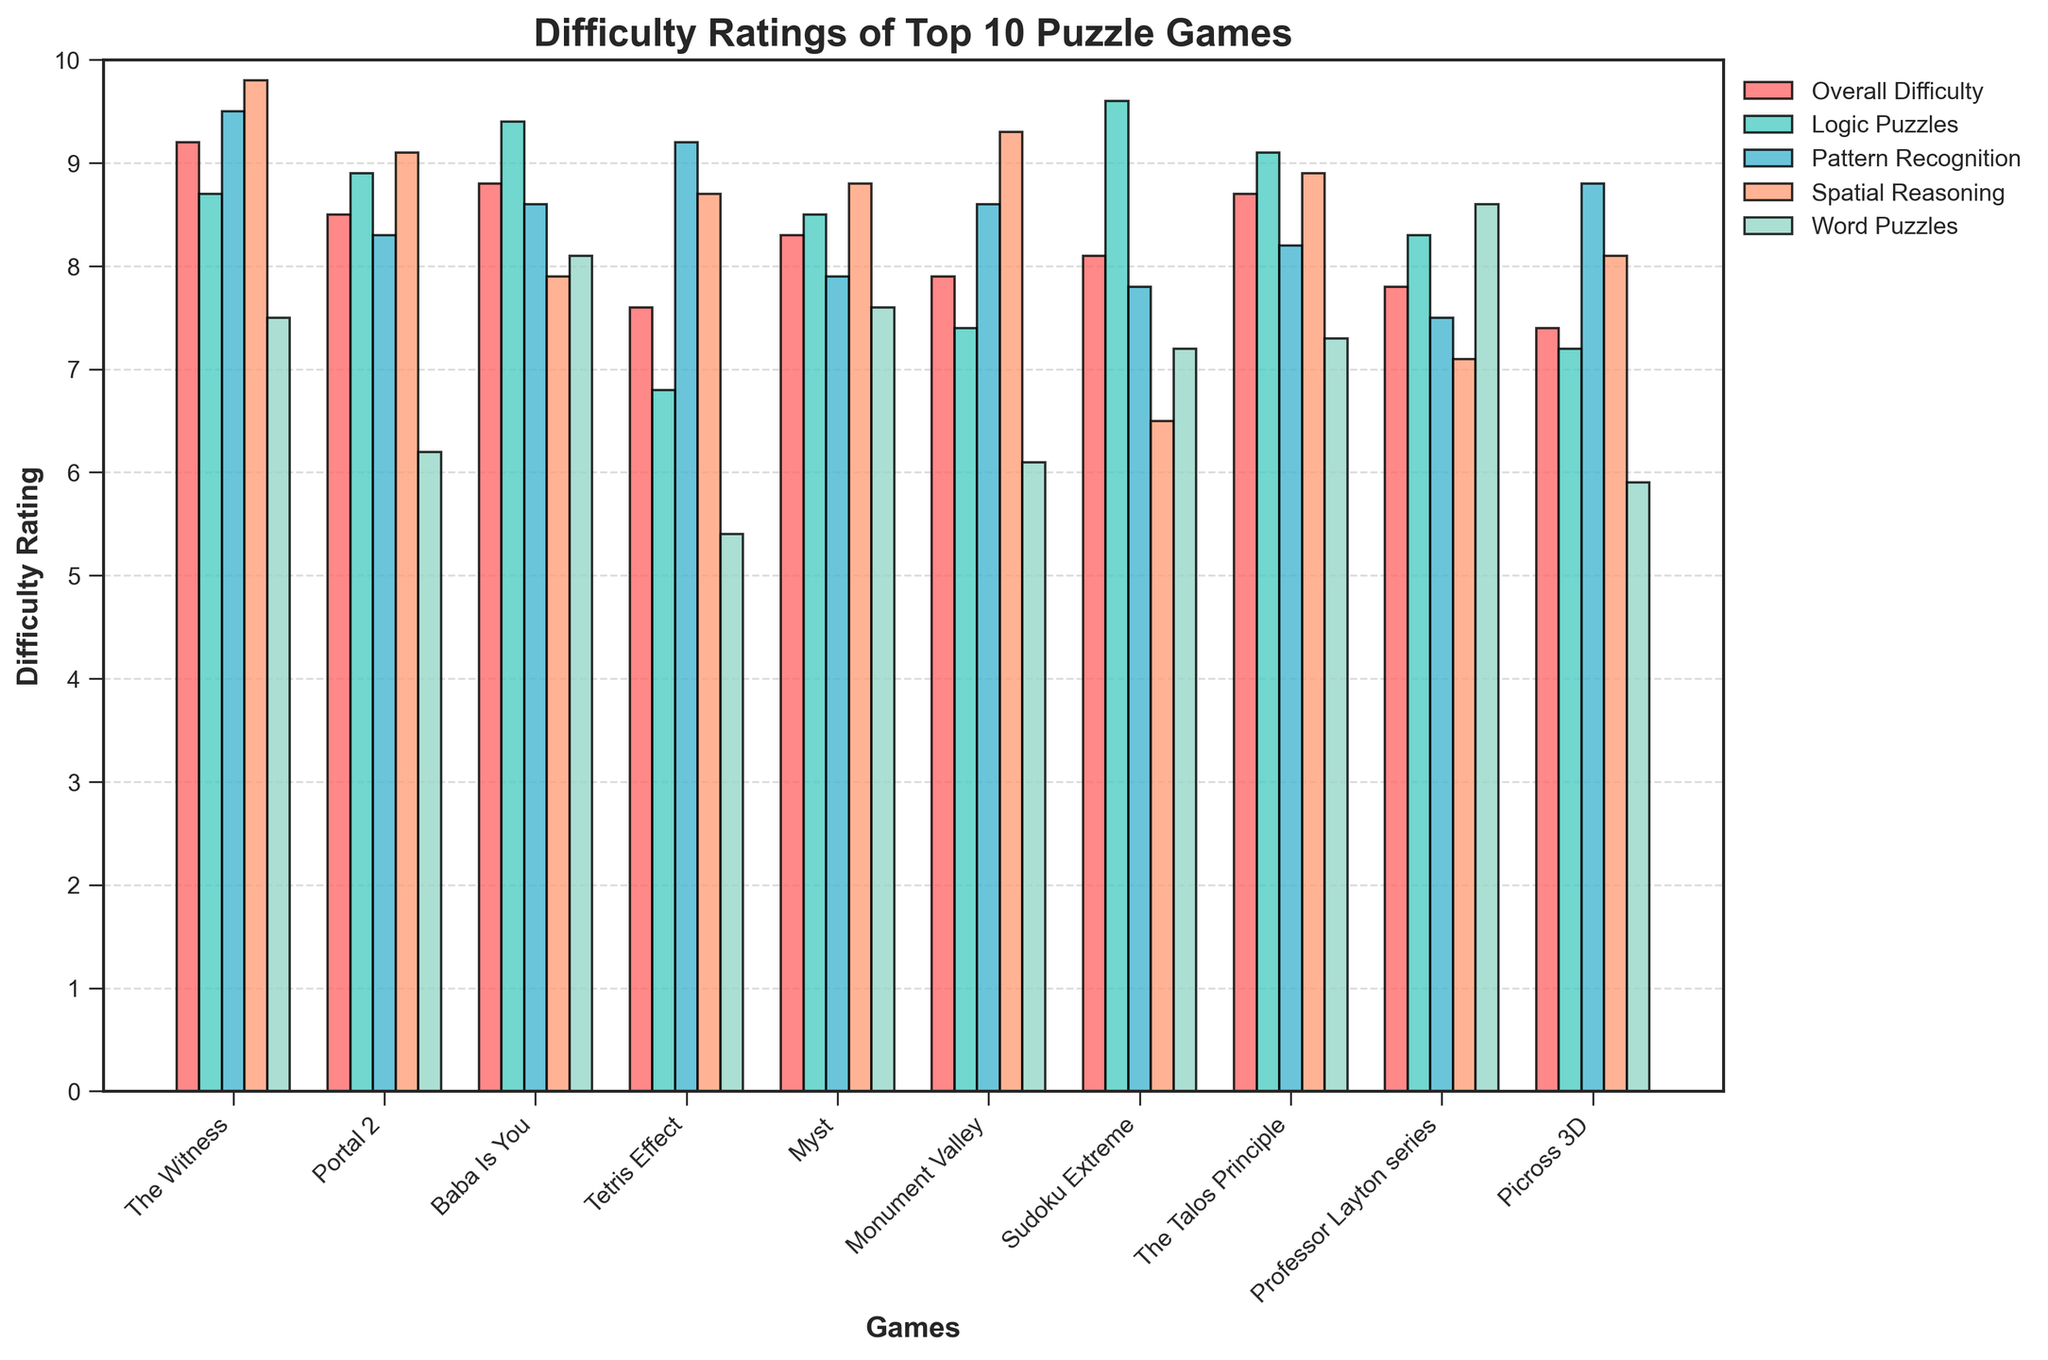Which game has the highest overall difficulty rating? First, identify the bar representing the overall difficulty. Then, observe the heights to find the tallest bar indicating the game with the highest rating.
Answer: The Witness Which puzzle game has the lowest rating for word puzzles? Identify the color corresponding to word puzzles, then look for the shortest bar of that color.
Answer: Tetris Effect Which game has the biggest difference between its spatial reasoning and logic puzzle ratings? For each game, subtract the logic puzzles rating from the spatial reasoning rating, and identify the game with the largest absolute difference. Detailed calculations show that "The Witness" has the maximum difference of 1.1 (9.8 - 8.7 = 1.1).
Answer: The Witness What is the average difficulty rating for logic puzzles across all games? Add up all the logic puzzle ratings and divide by the number of games. (8.7 + 8.9 + 9.4 + 6.8 + 8.5 + 7.4 + 9.6 + 9.1 + 8.3 + 7.2) / 10 = 8.39
Answer: 8.39 How many games have a pattern recognition difficulty rating higher than 8.5? Count the number of bars for pattern recognition taller than the 8.5 mark across all games. The games are "The Witness", "Baba Is You", "Monument Valley", and "Picross 3D".
Answer: 4 Is the difficulty rating for the Talos Principle's spatial reasoning higher than its overall difficulty rating? Compare the heights of the corresponding bars for the Talos Principle for spatial reasoning and overall difficulty. Overall difficulty = 8.7, Spatial reasoning = 8.9, thus spatial reasoning is higher.
Answer: Yes Which game has the smallest difference between its spatial reasoning and word puzzle ratings? For each game, find the absolute difference between spatial reasoning and word puzzle ratings and identify the smallest one. Calculations show "Myst" has the smallest difference of 1.2 (8.8 - 7.6 = 1.2).
Answer: Myst On average, do games have a higher difficulty rating for logic puzzles or pattern recognition? Calculate the average ratings for logic puzzles and pattern recognition across all games and compare. Logic puzzle average = 8.39, pattern recognition average = 8.44.
Answer: Pattern recognition What is the combined difficulty rating for "Portal 2" across all puzzle types? Add the difficulty ratings of all puzzle types for "Portal 2". 8.9 + 8.3 + 9.1 + 6.2 = 32.5
Answer: 32.5 Which game has the highest rating in spatial reasoning? Identify the color corresponding to spatial reasoning and find the tallest bar.
Answer: The Witness 